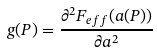<formula> <loc_0><loc_0><loc_500><loc_500>g ( P ) = \frac { \partial ^ { 2 } F _ { e f f } ( a ( P ) ) } { \partial a ^ { 2 } }</formula> 